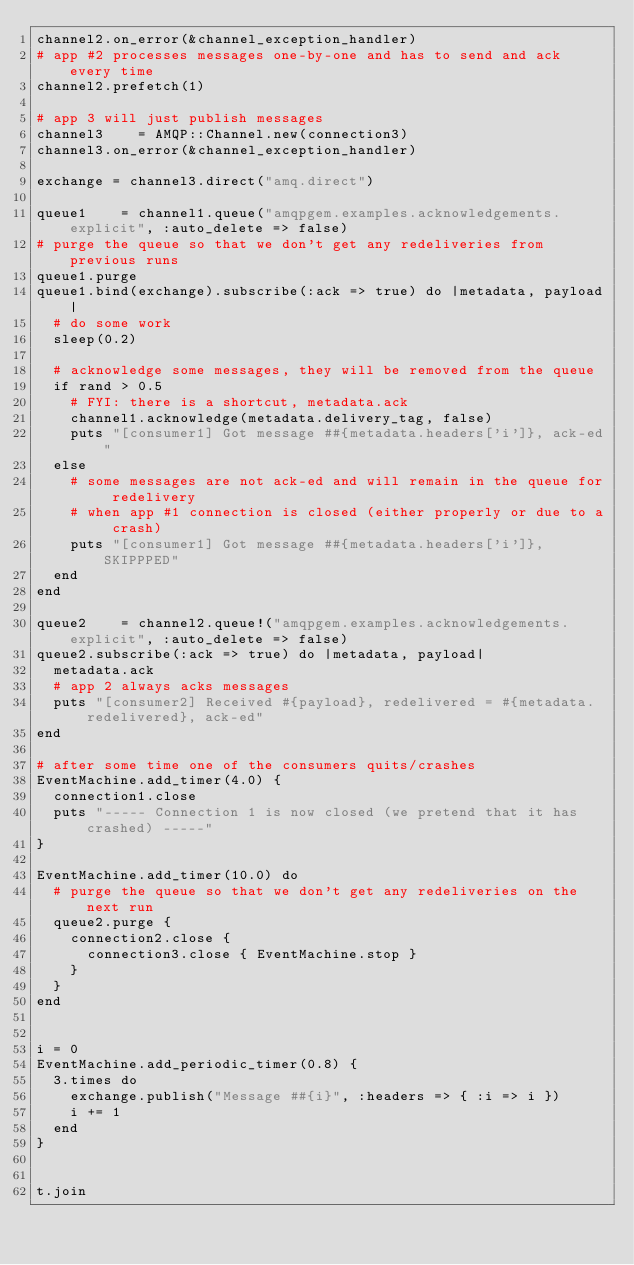Convert code to text. <code><loc_0><loc_0><loc_500><loc_500><_Ruby_>channel2.on_error(&channel_exception_handler)
# app #2 processes messages one-by-one and has to send and ack every time
channel2.prefetch(1)

# app 3 will just publish messages
channel3    = AMQP::Channel.new(connection3)
channel3.on_error(&channel_exception_handler)

exchange = channel3.direct("amq.direct")

queue1    = channel1.queue("amqpgem.examples.acknowledgements.explicit", :auto_delete => false)
# purge the queue so that we don't get any redeliveries from previous runs
queue1.purge
queue1.bind(exchange).subscribe(:ack => true) do |metadata, payload|
  # do some work
  sleep(0.2)

  # acknowledge some messages, they will be removed from the queue
  if rand > 0.5
    # FYI: there is a shortcut, metadata.ack
    channel1.acknowledge(metadata.delivery_tag, false)
    puts "[consumer1] Got message ##{metadata.headers['i']}, ack-ed"
  else
    # some messages are not ack-ed and will remain in the queue for redelivery
    # when app #1 connection is closed (either properly or due to a crash)
    puts "[consumer1] Got message ##{metadata.headers['i']}, SKIPPPED"
  end
end

queue2    = channel2.queue!("amqpgem.examples.acknowledgements.explicit", :auto_delete => false)
queue2.subscribe(:ack => true) do |metadata, payload|
  metadata.ack
  # app 2 always acks messages
  puts "[consumer2] Received #{payload}, redelivered = #{metadata.redelivered}, ack-ed"
end

# after some time one of the consumers quits/crashes
EventMachine.add_timer(4.0) {
  connection1.close
  puts "----- Connection 1 is now closed (we pretend that it has crashed) -----"
}

EventMachine.add_timer(10.0) do
  # purge the queue so that we don't get any redeliveries on the next run
  queue2.purge {
    connection2.close {
      connection3.close { EventMachine.stop }
    }
  }
end


i = 0
EventMachine.add_periodic_timer(0.8) {
  3.times do
    exchange.publish("Message ##{i}", :headers => { :i => i })
    i += 1
  end
}


t.join
</code> 